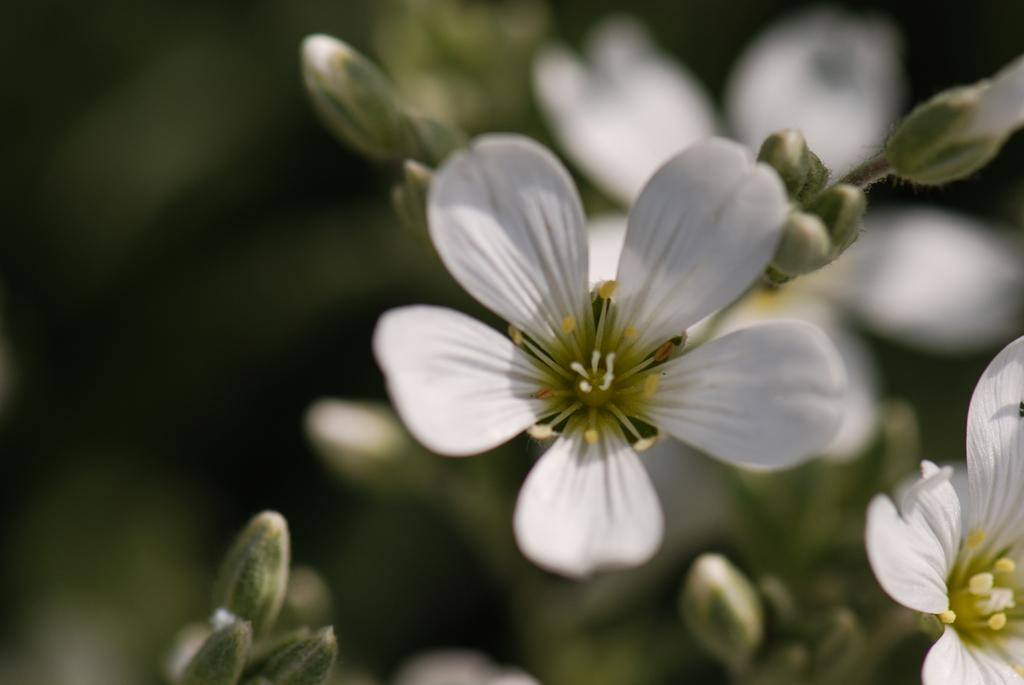What type of living organism is present in the image? There is a plant in the image. What color are the flowers on the plant? The flowers on the plant are white. Are there any unopened flowers on the plant? Yes, the plant has buds. Can you describe the background of the image? The background of the image is blurred. Are there any boats visible at the seashore in the image? There is no seashore or boats present in the image; it features a plant with white flowers and buds against a blurred background. 